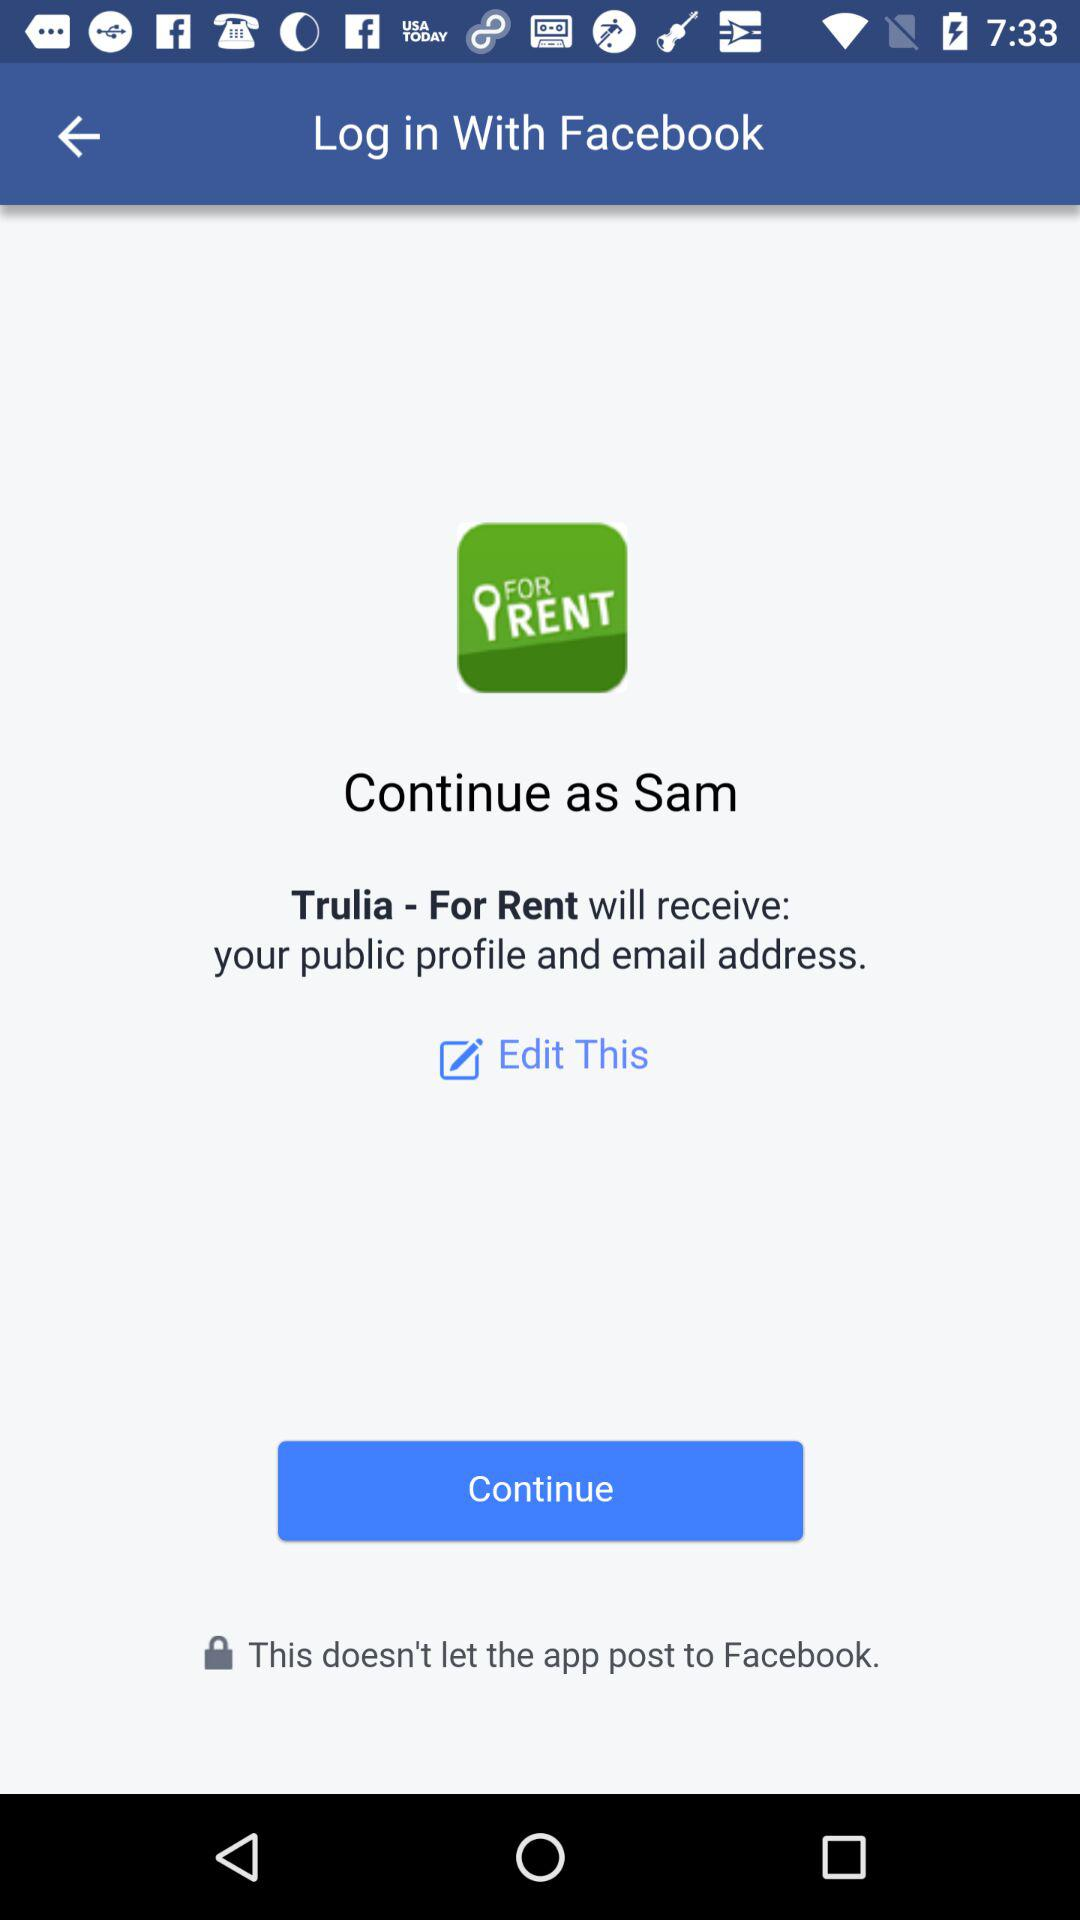What is the name of the user? The name of the user is Sam. 